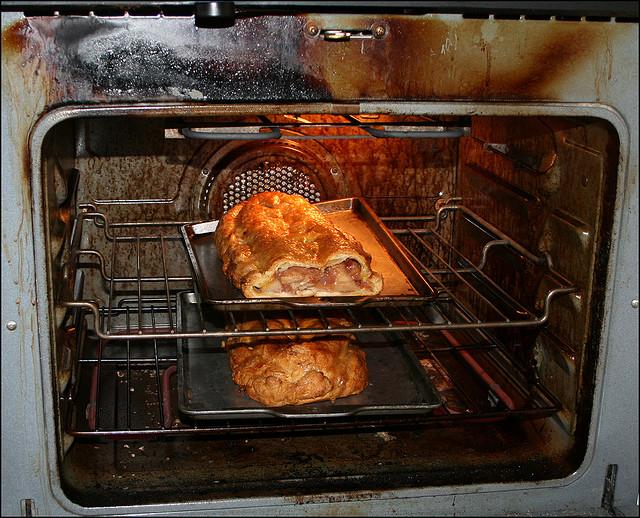What is cooking?
Give a very brief answer. Strudel. Does the oven appear to be on or off?
Quick response, please. On. Is there a pan in the image?
Concise answer only. Yes. Has the oven been cleaned?
Keep it brief. No. 